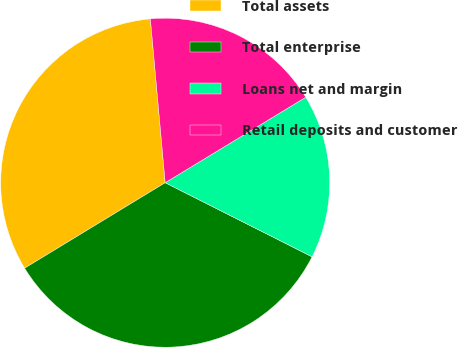Convert chart to OTSL. <chart><loc_0><loc_0><loc_500><loc_500><pie_chart><fcel>Total assets<fcel>Total enterprise<fcel>Loans net and margin<fcel>Retail deposits and customer<nl><fcel>32.26%<fcel>33.87%<fcel>16.13%<fcel>17.74%<nl></chart> 